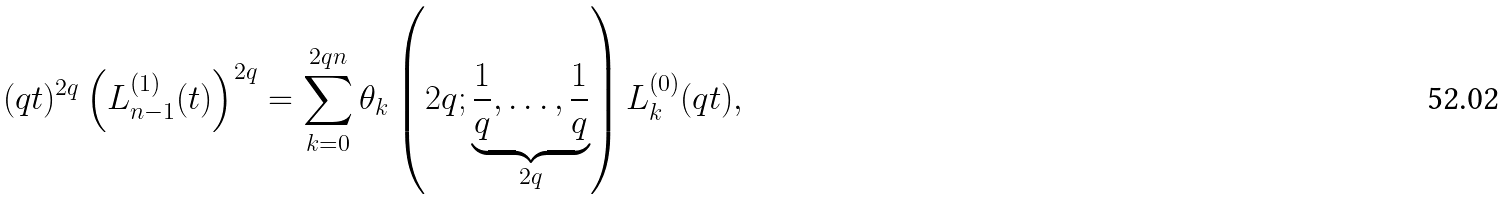Convert formula to latex. <formula><loc_0><loc_0><loc_500><loc_500>( q t ) ^ { 2 q } \left ( L _ { n - 1 } ^ { ( 1 ) } ( t ) \right ) ^ { 2 q } = \sum _ { k = 0 } ^ { 2 q n } \theta _ { k } \left ( 2 q ; \underbrace { \frac { 1 } { q } , \dots , \frac { 1 } { q } } _ { 2 q } \right ) L _ { k } ^ { ( 0 ) } ( q t ) ,</formula> 